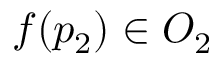<formula> <loc_0><loc_0><loc_500><loc_500>f ( p _ { 2 } ) \in O _ { 2 }</formula> 